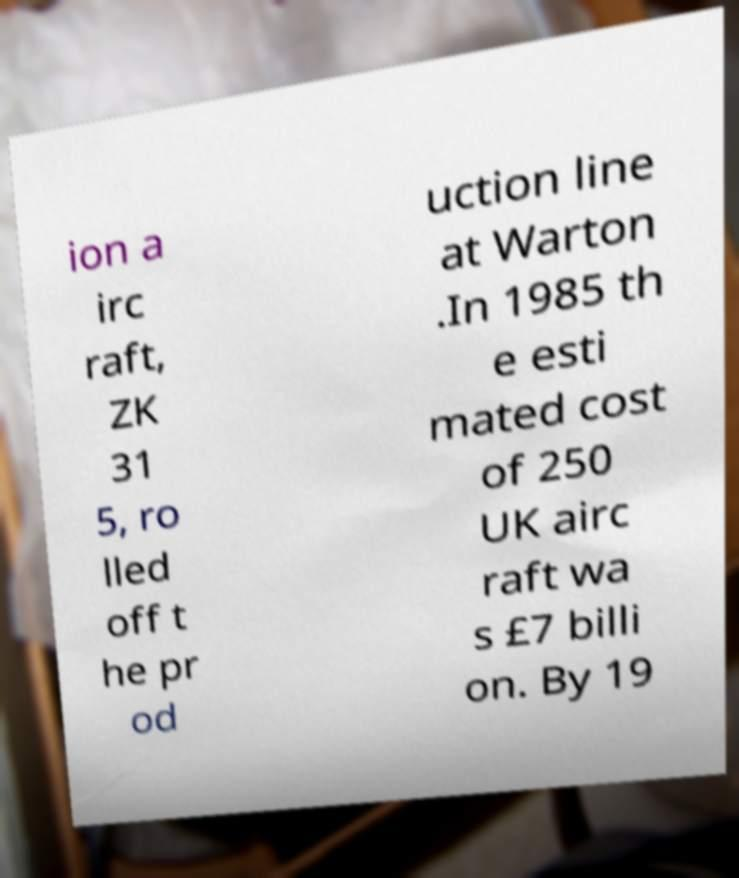Could you extract and type out the text from this image? ion a irc raft, ZK 31 5, ro lled off t he pr od uction line at Warton .In 1985 th e esti mated cost of 250 UK airc raft wa s £7 billi on. By 19 